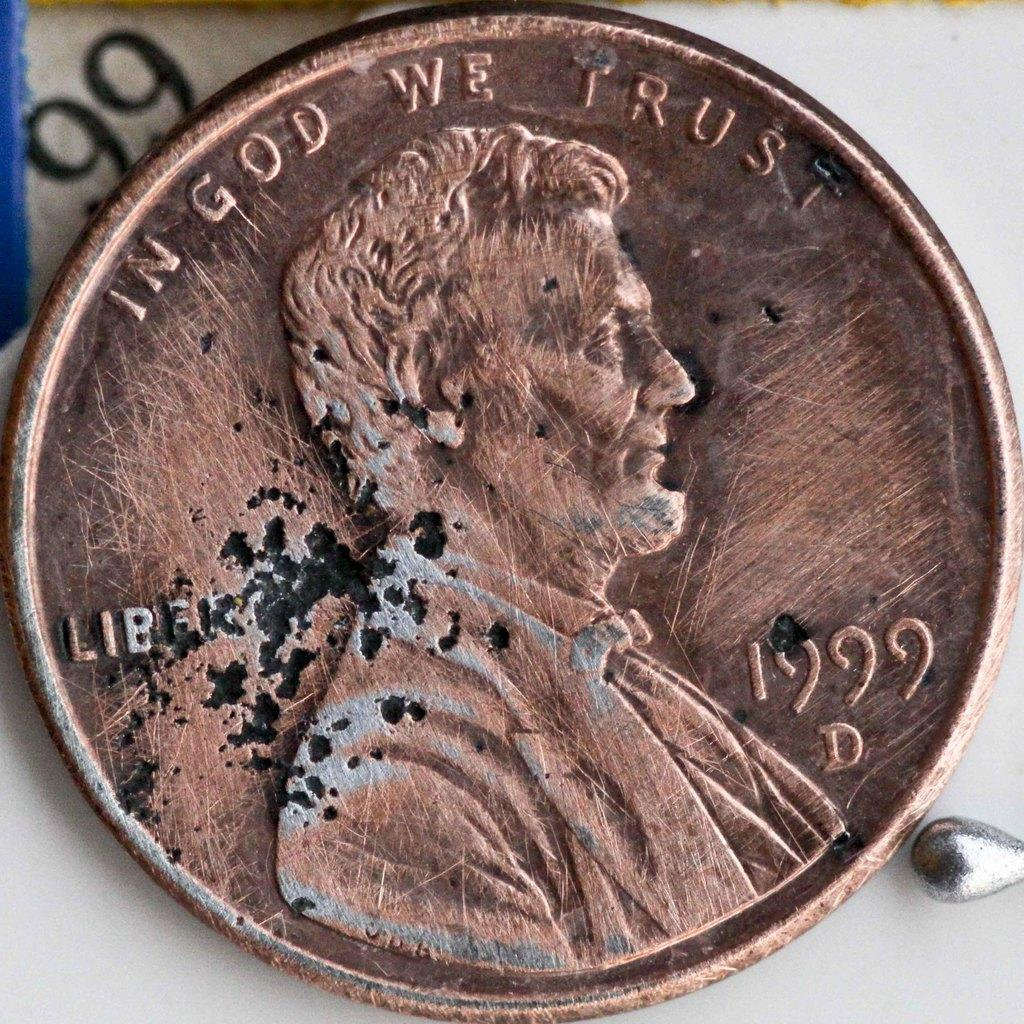<image>
Offer a succinct explanation of the picture presented. the date on the penny is 1999 and it also says liberty 